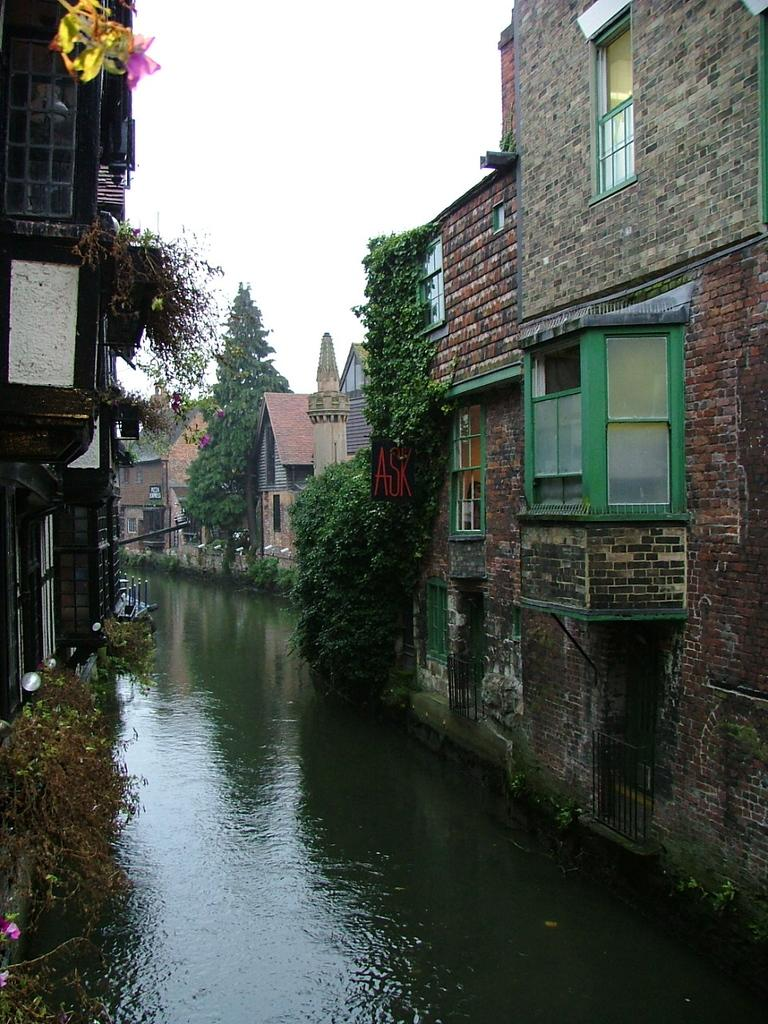What is at the bottom of the image? There is water at the bottom of the image, possibly a lake. What can be seen on either side of the water? There are many buildings on either side of the water. Are there any plants or vegetation in the image? Yes, there are trees in the image. What is visible at the top of the image? The sky is visible at the top of the image. What type of eggnog is being served at the event in the image? There is no event or eggnog present in the image; it features water, buildings, trees, and the sky. Can you see a plane flying in the sky in the image? There is no plane visible in the sky in the image. 